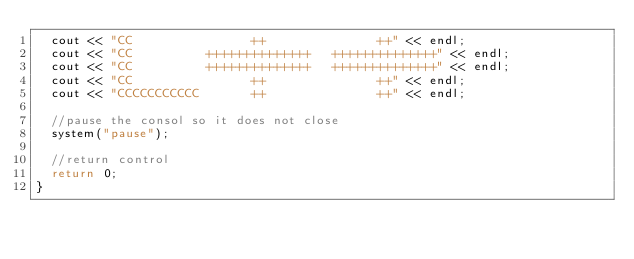Convert code to text. <code><loc_0><loc_0><loc_500><loc_500><_C++_>	cout << "CC                ++               ++" << endl;
	cout << "CC          ++++++++++++++   ++++++++++++++" << endl;
	cout << "CC          ++++++++++++++   ++++++++++++++" << endl;
	cout << "CC                ++               ++" << endl;
	cout << "CCCCCCCCCCC       ++               ++" << endl;

	//pause the consol so it does not close
	system("pause");
	
	//return control
	return 0;
}</code> 